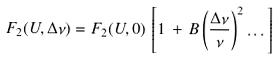<formula> <loc_0><loc_0><loc_500><loc_500>F _ { 2 } ( U , \Delta \nu ) = F _ { 2 } ( U , 0 ) \, \left [ 1 \, + \, B \left ( \frac { \Delta \nu } { \nu } \right ) ^ { 2 } \dots \right ]</formula> 